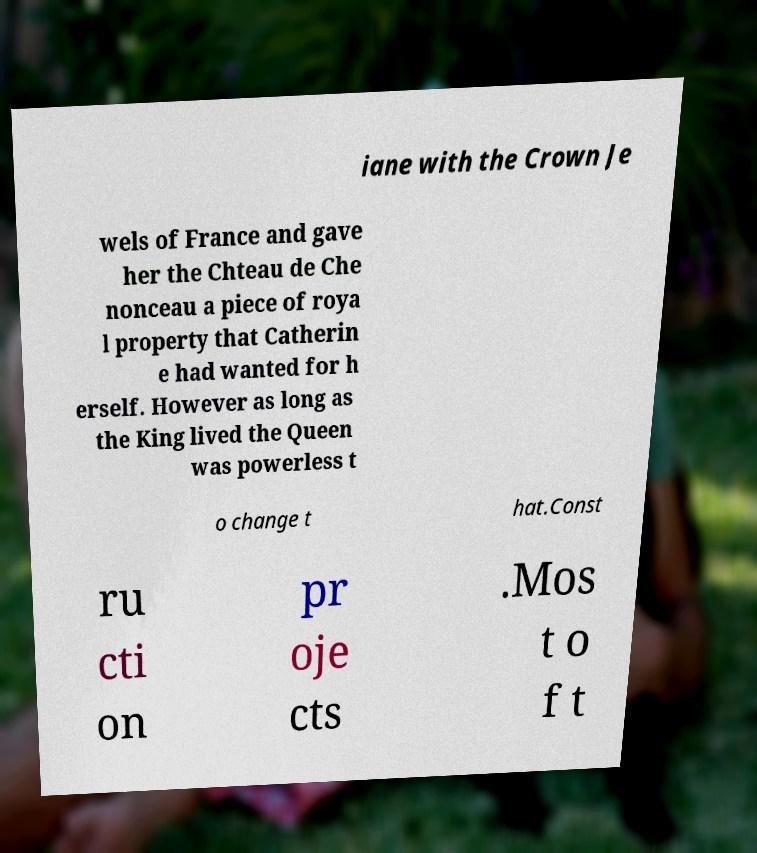There's text embedded in this image that I need extracted. Can you transcribe it verbatim? iane with the Crown Je wels of France and gave her the Chteau de Che nonceau a piece of roya l property that Catherin e had wanted for h erself. However as long as the King lived the Queen was powerless t o change t hat.Const ru cti on pr oje cts .Mos t o f t 